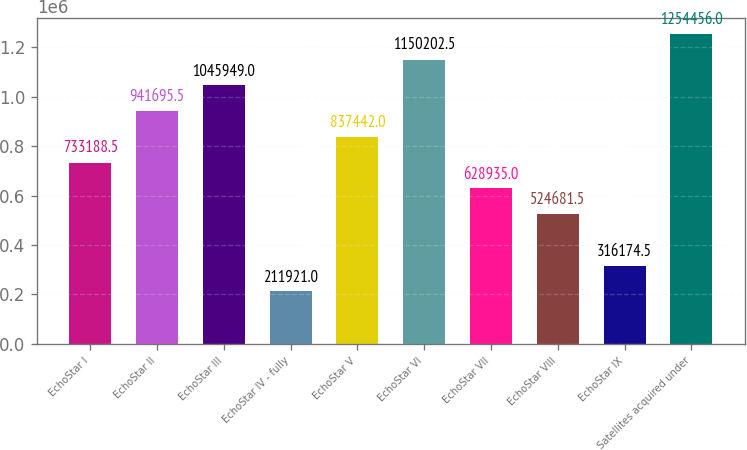Convert chart. <chart><loc_0><loc_0><loc_500><loc_500><bar_chart><fcel>EchoStar I<fcel>EchoStar II<fcel>EchoStar III<fcel>EchoStar IV - fully<fcel>EchoStar V<fcel>EchoStar VI<fcel>EchoStar VII<fcel>EchoStar VIII<fcel>EchoStar IX<fcel>Satellites acquired under<nl><fcel>733188<fcel>941696<fcel>1.04595e+06<fcel>211921<fcel>837442<fcel>1.1502e+06<fcel>628935<fcel>524682<fcel>316174<fcel>1.25446e+06<nl></chart> 